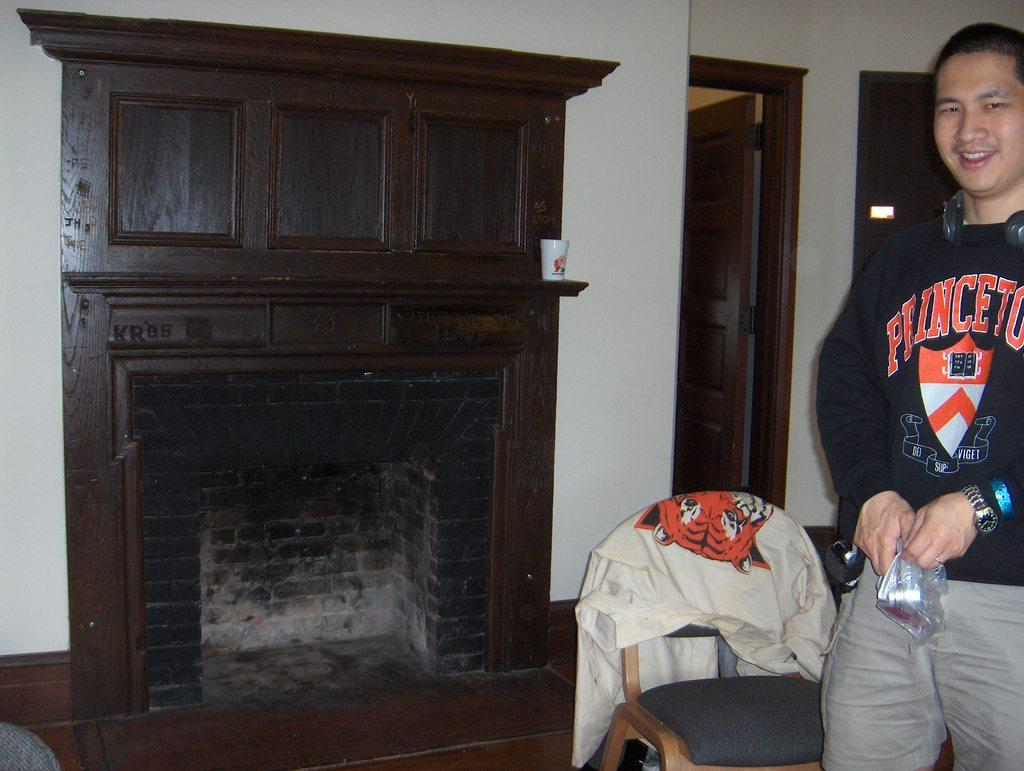<image>
Give a short and clear explanation of the subsequent image. Young man wearing a Princeton shirt standing next to a old fire place. 